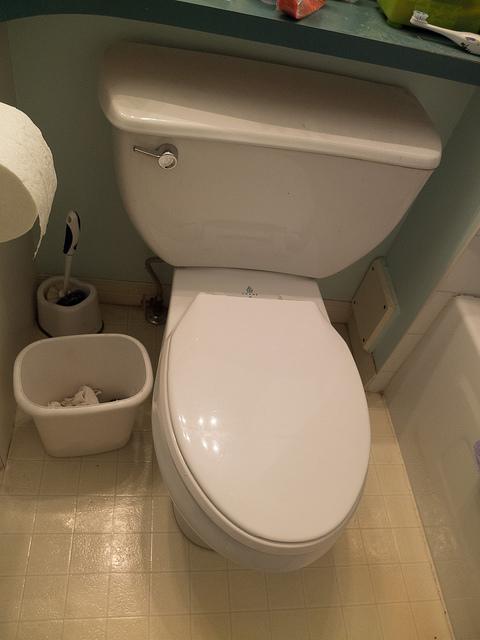Does the trash can need to be emptied?
Answer briefly. Yes. Is the toilet seat up or down?
Concise answer only. Down. Is this a heated seat?
Write a very short answer. No. Is there a sign on top of the toilet?
Be succinct. No. Is there anything special about this toilet?
Keep it brief. No. Is there a towel on the bathtub?
Answer briefly. No. Where is the toothbrush?
Answer briefly. Counter. What is the object with the blue and white handle used for?
Be succinct. Cleaning toilet. 